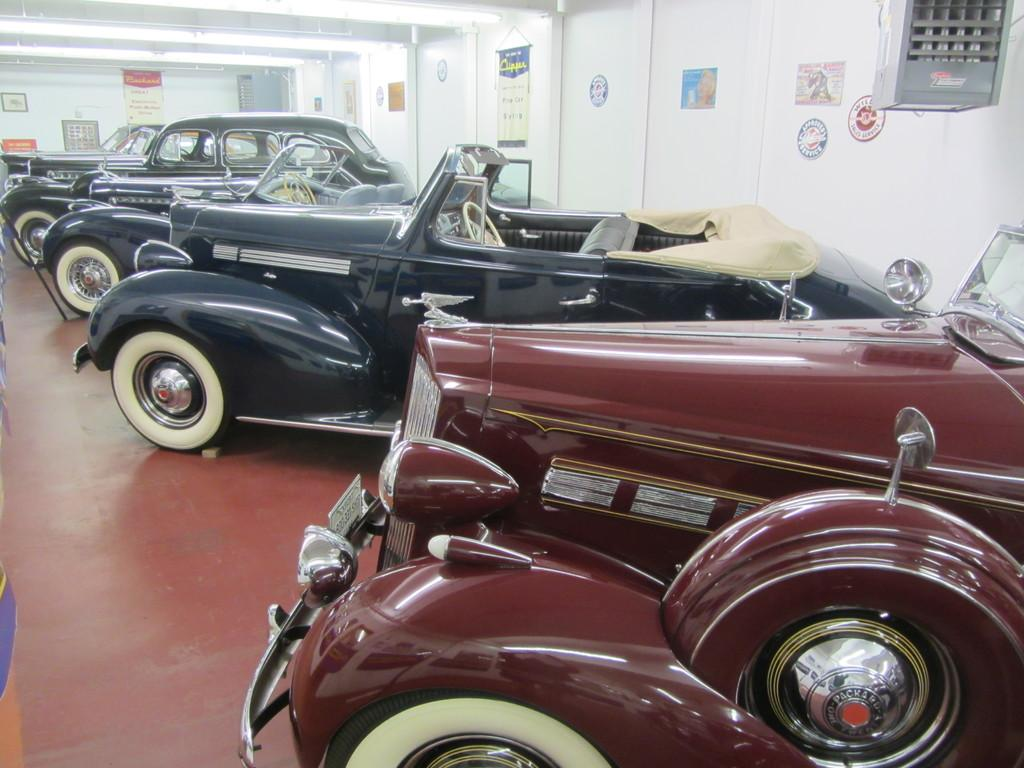What is the main subject in the center of the image? There are cars in the center of the image. What can be seen in the background of the image? There is a wall in the background of the image. What is placed on the wall? Boards are placed on the wall. What is visible at the top of the image? There are lights at the top of the image. What type of substance is being controlled by the parent in the image? There is no parent or substance present in the image. 